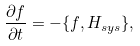Convert formula to latex. <formula><loc_0><loc_0><loc_500><loc_500>\frac { \partial f } { \partial t } = - \{ f , H _ { s y s } \} ,</formula> 